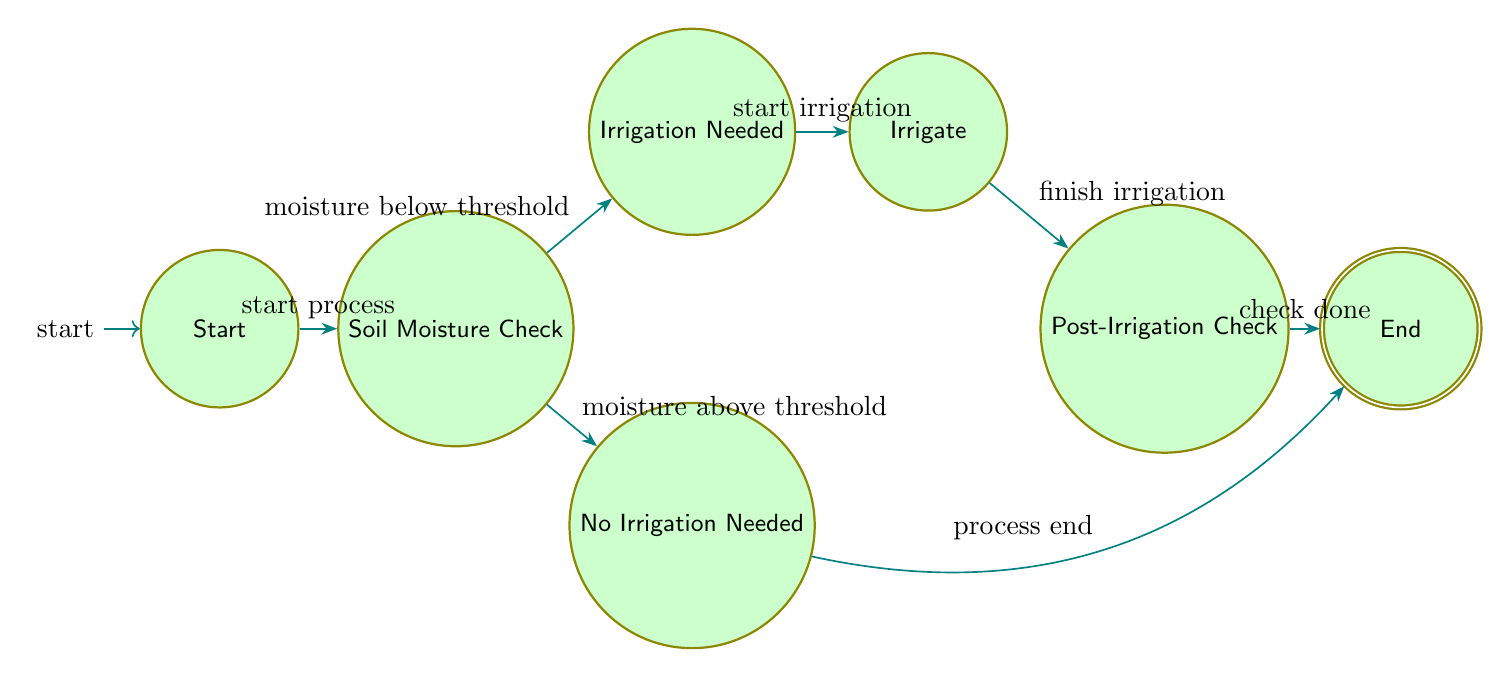What is the starting state of the irrigation process? The diagram indicates that the starting state is "Initial State." This is denoted by the "start" node on the far left.
Answer: Initial State How many nodes are in the diagram? There are a total of 7 nodes in the diagram representing the different states of the irrigation process. Counting each state listed shows this total.
Answer: 7 What happens after the soil moisture check if it's above the threshold? If the soil moisture is above the threshold, the process transitions to the "No Irrigation Needed" state, as indicated by the corresponding edge labeled "moisture above threshold."
Answer: No Irrigation Needed What is the final state reached after the post-irrigation check? After completing the post-irrigation check, the process transitions to the "End State," which represents the completion of the irrigation process. This is shown by the "check done" edge leading to the final node.
Answer: End State What condition leads to the transition from 'Soil Moisture Check' to 'Irrigation Needed'? The transition from 'Soil Moisture Check' to 'Irrigation Needed' occurs under the condition that the "moisture_below_threshold" is met, as indicated on the edge between these two nodes.
Answer: moisture_below_threshold Which node represents the action of performing irrigation? The node representing the action of performing irrigation is labeled "Irrigate." This node follows the "Irrigation Needed" state and precedes the "Post-Irrigation Check."
Answer: Irrigate What is triggered when irrigation is finished? The action that is triggered when irrigation is finished is labeled "finish irrigation," which leads to the "Post-Irrigation Check" state in the diagram.
Answer: finish irrigation If the soil moisture is below the threshold, what process follows? If the soil moisture is below the threshold, the next process that follows is to transition to the "Irrigation Needed" state, allowing the irrigation to be performed.
Answer: Irrigation Needed 